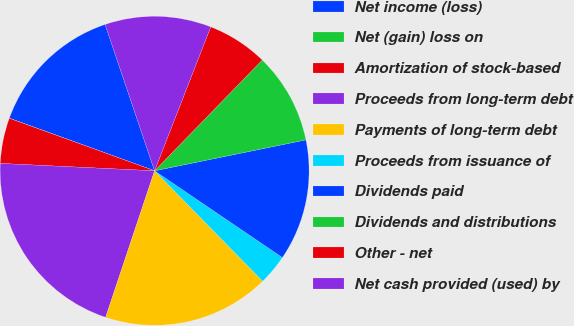<chart> <loc_0><loc_0><loc_500><loc_500><pie_chart><fcel>Net income (loss)<fcel>Net (gain) loss on<fcel>Amortization of stock-based<fcel>Proceeds from long-term debt<fcel>Payments of long-term debt<fcel>Proceeds from issuance of<fcel>Dividends paid<fcel>Dividends and distributions<fcel>Other - net<fcel>Net cash provided (used) by<nl><fcel>14.28%<fcel>0.01%<fcel>4.76%<fcel>20.63%<fcel>17.46%<fcel>3.18%<fcel>12.7%<fcel>9.52%<fcel>6.35%<fcel>11.11%<nl></chart> 